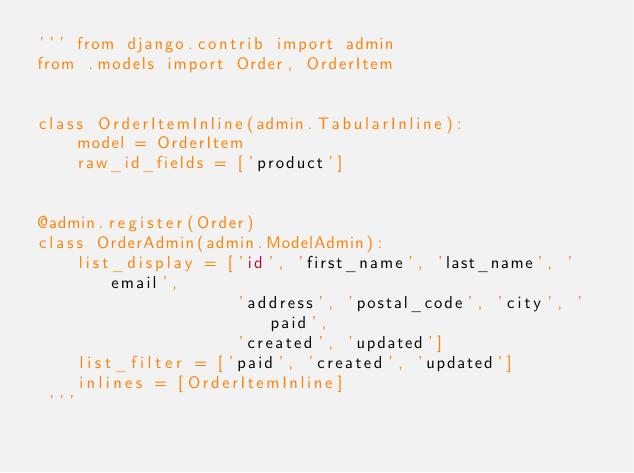Convert code to text. <code><loc_0><loc_0><loc_500><loc_500><_Python_>''' from django.contrib import admin
from .models import Order, OrderItem


class OrderItemInline(admin.TabularInline):
    model = OrderItem
    raw_id_fields = ['product']


@admin.register(Order)
class OrderAdmin(admin.ModelAdmin):
    list_display = ['id', 'first_name', 'last_name', 'email',
                    'address', 'postal_code', 'city', 'paid',
                    'created', 'updated']
    list_filter = ['paid', 'created', 'updated']
    inlines = [OrderItemInline]
 '''</code> 